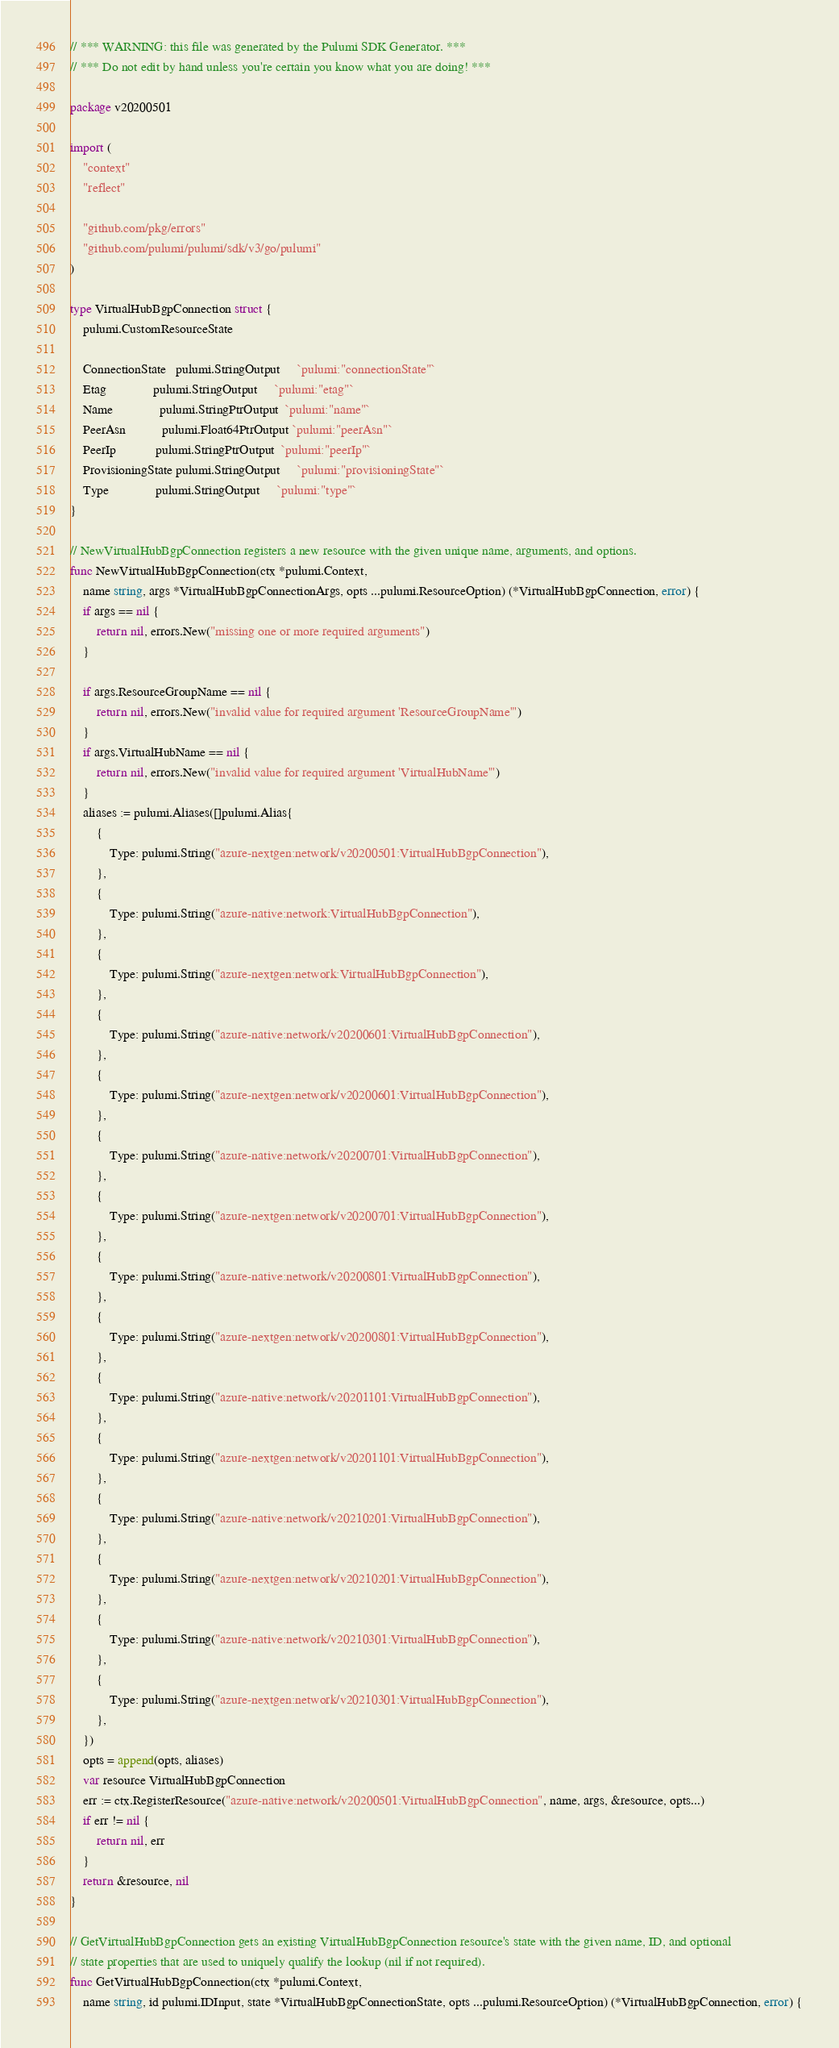Convert code to text. <code><loc_0><loc_0><loc_500><loc_500><_Go_>// *** WARNING: this file was generated by the Pulumi SDK Generator. ***
// *** Do not edit by hand unless you're certain you know what you are doing! ***

package v20200501

import (
	"context"
	"reflect"

	"github.com/pkg/errors"
	"github.com/pulumi/pulumi/sdk/v3/go/pulumi"
)

type VirtualHubBgpConnection struct {
	pulumi.CustomResourceState

	ConnectionState   pulumi.StringOutput     `pulumi:"connectionState"`
	Etag              pulumi.StringOutput     `pulumi:"etag"`
	Name              pulumi.StringPtrOutput  `pulumi:"name"`
	PeerAsn           pulumi.Float64PtrOutput `pulumi:"peerAsn"`
	PeerIp            pulumi.StringPtrOutput  `pulumi:"peerIp"`
	ProvisioningState pulumi.StringOutput     `pulumi:"provisioningState"`
	Type              pulumi.StringOutput     `pulumi:"type"`
}

// NewVirtualHubBgpConnection registers a new resource with the given unique name, arguments, and options.
func NewVirtualHubBgpConnection(ctx *pulumi.Context,
	name string, args *VirtualHubBgpConnectionArgs, opts ...pulumi.ResourceOption) (*VirtualHubBgpConnection, error) {
	if args == nil {
		return nil, errors.New("missing one or more required arguments")
	}

	if args.ResourceGroupName == nil {
		return nil, errors.New("invalid value for required argument 'ResourceGroupName'")
	}
	if args.VirtualHubName == nil {
		return nil, errors.New("invalid value for required argument 'VirtualHubName'")
	}
	aliases := pulumi.Aliases([]pulumi.Alias{
		{
			Type: pulumi.String("azure-nextgen:network/v20200501:VirtualHubBgpConnection"),
		},
		{
			Type: pulumi.String("azure-native:network:VirtualHubBgpConnection"),
		},
		{
			Type: pulumi.String("azure-nextgen:network:VirtualHubBgpConnection"),
		},
		{
			Type: pulumi.String("azure-native:network/v20200601:VirtualHubBgpConnection"),
		},
		{
			Type: pulumi.String("azure-nextgen:network/v20200601:VirtualHubBgpConnection"),
		},
		{
			Type: pulumi.String("azure-native:network/v20200701:VirtualHubBgpConnection"),
		},
		{
			Type: pulumi.String("azure-nextgen:network/v20200701:VirtualHubBgpConnection"),
		},
		{
			Type: pulumi.String("azure-native:network/v20200801:VirtualHubBgpConnection"),
		},
		{
			Type: pulumi.String("azure-nextgen:network/v20200801:VirtualHubBgpConnection"),
		},
		{
			Type: pulumi.String("azure-native:network/v20201101:VirtualHubBgpConnection"),
		},
		{
			Type: pulumi.String("azure-nextgen:network/v20201101:VirtualHubBgpConnection"),
		},
		{
			Type: pulumi.String("azure-native:network/v20210201:VirtualHubBgpConnection"),
		},
		{
			Type: pulumi.String("azure-nextgen:network/v20210201:VirtualHubBgpConnection"),
		},
		{
			Type: pulumi.String("azure-native:network/v20210301:VirtualHubBgpConnection"),
		},
		{
			Type: pulumi.String("azure-nextgen:network/v20210301:VirtualHubBgpConnection"),
		},
	})
	opts = append(opts, aliases)
	var resource VirtualHubBgpConnection
	err := ctx.RegisterResource("azure-native:network/v20200501:VirtualHubBgpConnection", name, args, &resource, opts...)
	if err != nil {
		return nil, err
	}
	return &resource, nil
}

// GetVirtualHubBgpConnection gets an existing VirtualHubBgpConnection resource's state with the given name, ID, and optional
// state properties that are used to uniquely qualify the lookup (nil if not required).
func GetVirtualHubBgpConnection(ctx *pulumi.Context,
	name string, id pulumi.IDInput, state *VirtualHubBgpConnectionState, opts ...pulumi.ResourceOption) (*VirtualHubBgpConnection, error) {</code> 